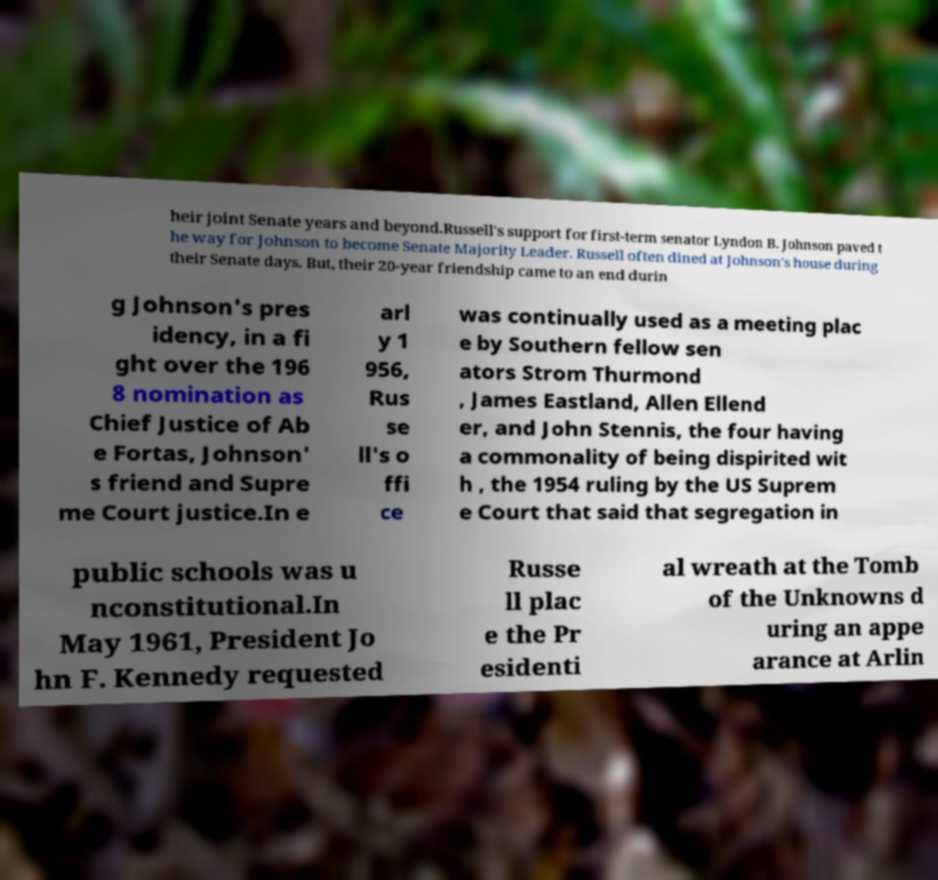Can you read and provide the text displayed in the image?This photo seems to have some interesting text. Can you extract and type it out for me? heir joint Senate years and beyond.Russell's support for first-term senator Lyndon B. Johnson paved t he way for Johnson to become Senate Majority Leader. Russell often dined at Johnson's house during their Senate days. But, their 20-year friendship came to an end durin g Johnson's pres idency, in a fi ght over the 196 8 nomination as Chief Justice of Ab e Fortas, Johnson' s friend and Supre me Court justice.In e arl y 1 956, Rus se ll's o ffi ce was continually used as a meeting plac e by Southern fellow sen ators Strom Thurmond , James Eastland, Allen Ellend er, and John Stennis, the four having a commonality of being dispirited wit h , the 1954 ruling by the US Suprem e Court that said that segregation in public schools was u nconstitutional.In May 1961, President Jo hn F. Kennedy requested Russe ll plac e the Pr esidenti al wreath at the Tomb of the Unknowns d uring an appe arance at Arlin 